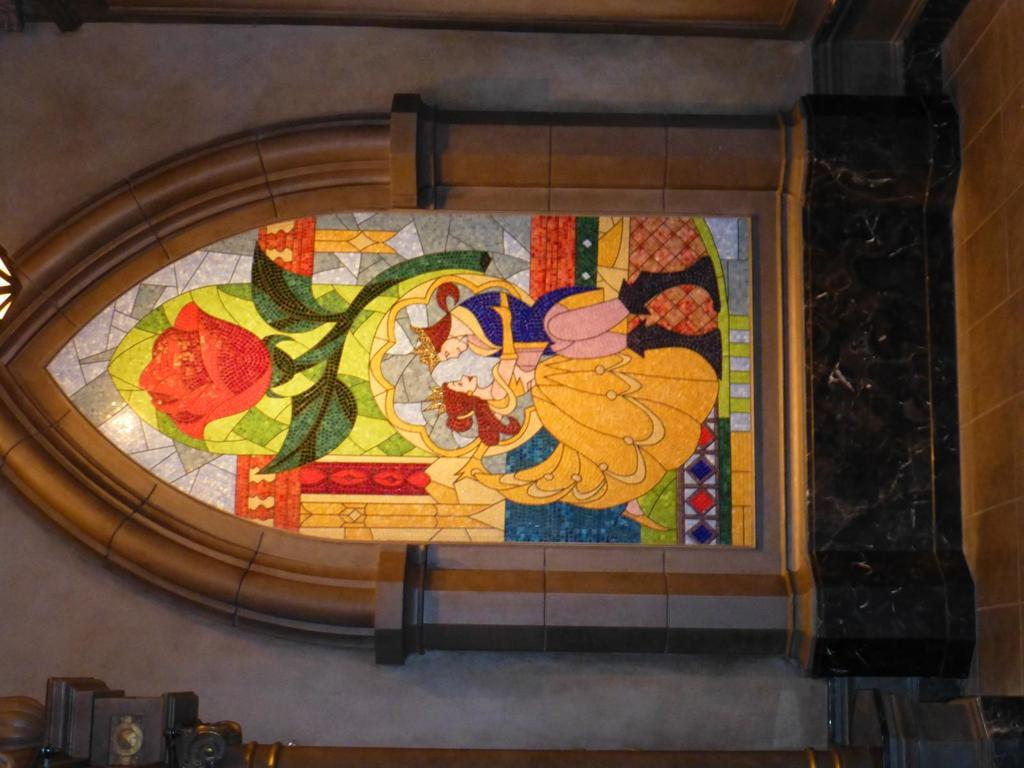What is the main subject in the foreground of the image? There is a building wall in the foreground of the image. What is depicted on the building wall? There is a wall painting on the building wall. Can you make any assumptions about the location of the image based on the wall painting? The image may have been taken in a church, as the wall painting could depict a religious scene or symbol. What color crayon is being used to draw on the wall in the image? There is no crayon present in the image, and no one is drawing on the wall. 